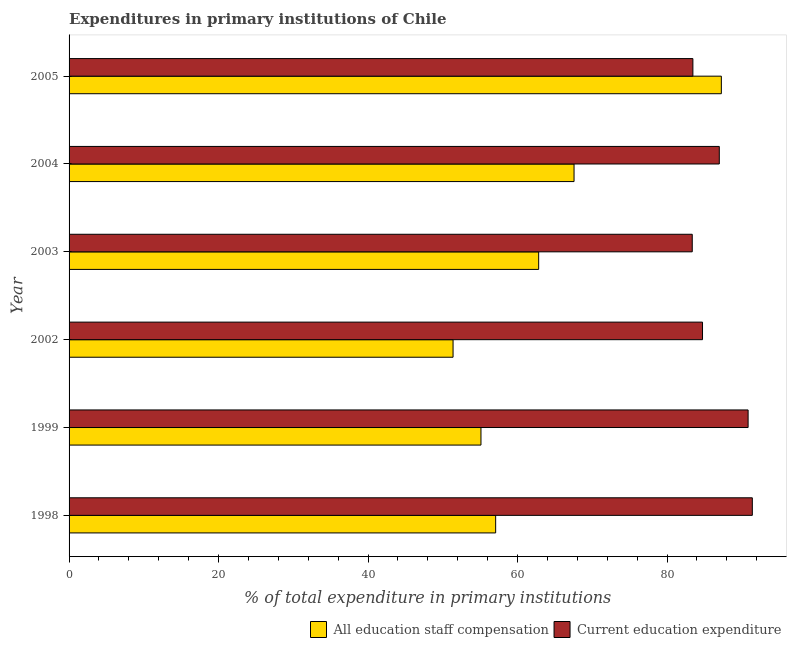How many groups of bars are there?
Provide a short and direct response. 6. Are the number of bars per tick equal to the number of legend labels?
Offer a terse response. Yes. How many bars are there on the 3rd tick from the top?
Provide a succinct answer. 2. How many bars are there on the 2nd tick from the bottom?
Your response must be concise. 2. In how many cases, is the number of bars for a given year not equal to the number of legend labels?
Offer a terse response. 0. What is the expenditure in education in 2005?
Your answer should be compact. 83.46. Across all years, what is the maximum expenditure in education?
Your answer should be very brief. 91.41. Across all years, what is the minimum expenditure in education?
Keep it short and to the point. 83.37. In which year was the expenditure in staff compensation maximum?
Your answer should be compact. 2005. What is the total expenditure in education in the graph?
Provide a succinct answer. 520.81. What is the difference between the expenditure in education in 1999 and that in 2005?
Your answer should be very brief. 7.39. What is the difference between the expenditure in staff compensation in 1998 and the expenditure in education in 2005?
Offer a terse response. -26.39. What is the average expenditure in education per year?
Offer a very short reply. 86.8. In the year 1999, what is the difference between the expenditure in staff compensation and expenditure in education?
Your response must be concise. -35.74. What is the ratio of the expenditure in staff compensation in 1998 to that in 1999?
Keep it short and to the point. 1.04. Is the expenditure in education in 1998 less than that in 2003?
Your response must be concise. No. What is the difference between the highest and the second highest expenditure in staff compensation?
Ensure brevity in your answer.  19.71. What is the difference between the highest and the lowest expenditure in education?
Make the answer very short. 8.04. Is the sum of the expenditure in education in 2002 and 2003 greater than the maximum expenditure in staff compensation across all years?
Your answer should be compact. Yes. What does the 2nd bar from the top in 1999 represents?
Make the answer very short. All education staff compensation. What does the 1st bar from the bottom in 1999 represents?
Your response must be concise. All education staff compensation. Are all the bars in the graph horizontal?
Keep it short and to the point. Yes. How many years are there in the graph?
Offer a very short reply. 6. Are the values on the major ticks of X-axis written in scientific E-notation?
Give a very brief answer. No. How are the legend labels stacked?
Provide a short and direct response. Horizontal. What is the title of the graph?
Make the answer very short. Expenditures in primary institutions of Chile. Does "Manufacturing industries and construction" appear as one of the legend labels in the graph?
Offer a very short reply. No. What is the label or title of the X-axis?
Keep it short and to the point. % of total expenditure in primary institutions. What is the label or title of the Y-axis?
Your answer should be very brief. Year. What is the % of total expenditure in primary institutions in All education staff compensation in 1998?
Provide a short and direct response. 57.07. What is the % of total expenditure in primary institutions of Current education expenditure in 1998?
Provide a short and direct response. 91.41. What is the % of total expenditure in primary institutions in All education staff compensation in 1999?
Offer a terse response. 55.1. What is the % of total expenditure in primary institutions in Current education expenditure in 1999?
Keep it short and to the point. 90.84. What is the % of total expenditure in primary institutions in All education staff compensation in 2002?
Ensure brevity in your answer.  51.37. What is the % of total expenditure in primary institutions in Current education expenditure in 2002?
Offer a very short reply. 84.74. What is the % of total expenditure in primary institutions in All education staff compensation in 2003?
Your response must be concise. 62.82. What is the % of total expenditure in primary institutions of Current education expenditure in 2003?
Your answer should be compact. 83.37. What is the % of total expenditure in primary institutions in All education staff compensation in 2004?
Keep it short and to the point. 67.56. What is the % of total expenditure in primary institutions in Current education expenditure in 2004?
Your answer should be compact. 86.99. What is the % of total expenditure in primary institutions of All education staff compensation in 2005?
Give a very brief answer. 87.26. What is the % of total expenditure in primary institutions in Current education expenditure in 2005?
Your response must be concise. 83.46. Across all years, what is the maximum % of total expenditure in primary institutions in All education staff compensation?
Make the answer very short. 87.26. Across all years, what is the maximum % of total expenditure in primary institutions in Current education expenditure?
Make the answer very short. 91.41. Across all years, what is the minimum % of total expenditure in primary institutions of All education staff compensation?
Keep it short and to the point. 51.37. Across all years, what is the minimum % of total expenditure in primary institutions of Current education expenditure?
Keep it short and to the point. 83.37. What is the total % of total expenditure in primary institutions of All education staff compensation in the graph?
Offer a terse response. 381.19. What is the total % of total expenditure in primary institutions of Current education expenditure in the graph?
Ensure brevity in your answer.  520.81. What is the difference between the % of total expenditure in primary institutions of All education staff compensation in 1998 and that in 1999?
Your answer should be compact. 1.97. What is the difference between the % of total expenditure in primary institutions of Current education expenditure in 1998 and that in 1999?
Your answer should be compact. 0.56. What is the difference between the % of total expenditure in primary institutions in All education staff compensation in 1998 and that in 2002?
Your answer should be compact. 5.7. What is the difference between the % of total expenditure in primary institutions of Current education expenditure in 1998 and that in 2002?
Offer a very short reply. 6.66. What is the difference between the % of total expenditure in primary institutions in All education staff compensation in 1998 and that in 2003?
Your response must be concise. -5.75. What is the difference between the % of total expenditure in primary institutions of Current education expenditure in 1998 and that in 2003?
Your answer should be compact. 8.04. What is the difference between the % of total expenditure in primary institutions in All education staff compensation in 1998 and that in 2004?
Provide a succinct answer. -10.49. What is the difference between the % of total expenditure in primary institutions of Current education expenditure in 1998 and that in 2004?
Your answer should be very brief. 4.42. What is the difference between the % of total expenditure in primary institutions of All education staff compensation in 1998 and that in 2005?
Give a very brief answer. -30.19. What is the difference between the % of total expenditure in primary institutions of Current education expenditure in 1998 and that in 2005?
Your answer should be very brief. 7.95. What is the difference between the % of total expenditure in primary institutions of All education staff compensation in 1999 and that in 2002?
Make the answer very short. 3.73. What is the difference between the % of total expenditure in primary institutions in Current education expenditure in 1999 and that in 2002?
Ensure brevity in your answer.  6.1. What is the difference between the % of total expenditure in primary institutions of All education staff compensation in 1999 and that in 2003?
Ensure brevity in your answer.  -7.72. What is the difference between the % of total expenditure in primary institutions of Current education expenditure in 1999 and that in 2003?
Make the answer very short. 7.47. What is the difference between the % of total expenditure in primary institutions of All education staff compensation in 1999 and that in 2004?
Your response must be concise. -12.45. What is the difference between the % of total expenditure in primary institutions in Current education expenditure in 1999 and that in 2004?
Your response must be concise. 3.85. What is the difference between the % of total expenditure in primary institutions in All education staff compensation in 1999 and that in 2005?
Make the answer very short. -32.16. What is the difference between the % of total expenditure in primary institutions in Current education expenditure in 1999 and that in 2005?
Keep it short and to the point. 7.39. What is the difference between the % of total expenditure in primary institutions in All education staff compensation in 2002 and that in 2003?
Offer a very short reply. -11.45. What is the difference between the % of total expenditure in primary institutions of Current education expenditure in 2002 and that in 2003?
Keep it short and to the point. 1.37. What is the difference between the % of total expenditure in primary institutions of All education staff compensation in 2002 and that in 2004?
Keep it short and to the point. -16.19. What is the difference between the % of total expenditure in primary institutions of Current education expenditure in 2002 and that in 2004?
Ensure brevity in your answer.  -2.24. What is the difference between the % of total expenditure in primary institutions of All education staff compensation in 2002 and that in 2005?
Offer a terse response. -35.89. What is the difference between the % of total expenditure in primary institutions in Current education expenditure in 2002 and that in 2005?
Provide a short and direct response. 1.29. What is the difference between the % of total expenditure in primary institutions of All education staff compensation in 2003 and that in 2004?
Ensure brevity in your answer.  -4.73. What is the difference between the % of total expenditure in primary institutions in Current education expenditure in 2003 and that in 2004?
Make the answer very short. -3.62. What is the difference between the % of total expenditure in primary institutions in All education staff compensation in 2003 and that in 2005?
Provide a short and direct response. -24.44. What is the difference between the % of total expenditure in primary institutions of Current education expenditure in 2003 and that in 2005?
Give a very brief answer. -0.09. What is the difference between the % of total expenditure in primary institutions in All education staff compensation in 2004 and that in 2005?
Your answer should be very brief. -19.71. What is the difference between the % of total expenditure in primary institutions in Current education expenditure in 2004 and that in 2005?
Your answer should be compact. 3.53. What is the difference between the % of total expenditure in primary institutions in All education staff compensation in 1998 and the % of total expenditure in primary institutions in Current education expenditure in 1999?
Offer a very short reply. -33.77. What is the difference between the % of total expenditure in primary institutions of All education staff compensation in 1998 and the % of total expenditure in primary institutions of Current education expenditure in 2002?
Make the answer very short. -27.67. What is the difference between the % of total expenditure in primary institutions in All education staff compensation in 1998 and the % of total expenditure in primary institutions in Current education expenditure in 2003?
Provide a succinct answer. -26.3. What is the difference between the % of total expenditure in primary institutions of All education staff compensation in 1998 and the % of total expenditure in primary institutions of Current education expenditure in 2004?
Make the answer very short. -29.92. What is the difference between the % of total expenditure in primary institutions in All education staff compensation in 1998 and the % of total expenditure in primary institutions in Current education expenditure in 2005?
Make the answer very short. -26.39. What is the difference between the % of total expenditure in primary institutions in All education staff compensation in 1999 and the % of total expenditure in primary institutions in Current education expenditure in 2002?
Provide a short and direct response. -29.64. What is the difference between the % of total expenditure in primary institutions of All education staff compensation in 1999 and the % of total expenditure in primary institutions of Current education expenditure in 2003?
Provide a short and direct response. -28.27. What is the difference between the % of total expenditure in primary institutions of All education staff compensation in 1999 and the % of total expenditure in primary institutions of Current education expenditure in 2004?
Offer a very short reply. -31.88. What is the difference between the % of total expenditure in primary institutions in All education staff compensation in 1999 and the % of total expenditure in primary institutions in Current education expenditure in 2005?
Give a very brief answer. -28.35. What is the difference between the % of total expenditure in primary institutions in All education staff compensation in 2002 and the % of total expenditure in primary institutions in Current education expenditure in 2003?
Your response must be concise. -32. What is the difference between the % of total expenditure in primary institutions of All education staff compensation in 2002 and the % of total expenditure in primary institutions of Current education expenditure in 2004?
Ensure brevity in your answer.  -35.62. What is the difference between the % of total expenditure in primary institutions in All education staff compensation in 2002 and the % of total expenditure in primary institutions in Current education expenditure in 2005?
Keep it short and to the point. -32.09. What is the difference between the % of total expenditure in primary institutions of All education staff compensation in 2003 and the % of total expenditure in primary institutions of Current education expenditure in 2004?
Offer a very short reply. -24.16. What is the difference between the % of total expenditure in primary institutions in All education staff compensation in 2003 and the % of total expenditure in primary institutions in Current education expenditure in 2005?
Keep it short and to the point. -20.63. What is the difference between the % of total expenditure in primary institutions of All education staff compensation in 2004 and the % of total expenditure in primary institutions of Current education expenditure in 2005?
Ensure brevity in your answer.  -15.9. What is the average % of total expenditure in primary institutions in All education staff compensation per year?
Your response must be concise. 63.53. What is the average % of total expenditure in primary institutions of Current education expenditure per year?
Offer a terse response. 86.8. In the year 1998, what is the difference between the % of total expenditure in primary institutions of All education staff compensation and % of total expenditure in primary institutions of Current education expenditure?
Provide a short and direct response. -34.34. In the year 1999, what is the difference between the % of total expenditure in primary institutions in All education staff compensation and % of total expenditure in primary institutions in Current education expenditure?
Make the answer very short. -35.74. In the year 2002, what is the difference between the % of total expenditure in primary institutions of All education staff compensation and % of total expenditure in primary institutions of Current education expenditure?
Provide a short and direct response. -33.37. In the year 2003, what is the difference between the % of total expenditure in primary institutions of All education staff compensation and % of total expenditure in primary institutions of Current education expenditure?
Your response must be concise. -20.55. In the year 2004, what is the difference between the % of total expenditure in primary institutions in All education staff compensation and % of total expenditure in primary institutions in Current education expenditure?
Make the answer very short. -19.43. In the year 2005, what is the difference between the % of total expenditure in primary institutions in All education staff compensation and % of total expenditure in primary institutions in Current education expenditure?
Offer a very short reply. 3.81. What is the ratio of the % of total expenditure in primary institutions of All education staff compensation in 1998 to that in 1999?
Offer a very short reply. 1.04. What is the ratio of the % of total expenditure in primary institutions in All education staff compensation in 1998 to that in 2002?
Give a very brief answer. 1.11. What is the ratio of the % of total expenditure in primary institutions of Current education expenditure in 1998 to that in 2002?
Your response must be concise. 1.08. What is the ratio of the % of total expenditure in primary institutions in All education staff compensation in 1998 to that in 2003?
Give a very brief answer. 0.91. What is the ratio of the % of total expenditure in primary institutions in Current education expenditure in 1998 to that in 2003?
Make the answer very short. 1.1. What is the ratio of the % of total expenditure in primary institutions of All education staff compensation in 1998 to that in 2004?
Provide a succinct answer. 0.84. What is the ratio of the % of total expenditure in primary institutions of Current education expenditure in 1998 to that in 2004?
Keep it short and to the point. 1.05. What is the ratio of the % of total expenditure in primary institutions of All education staff compensation in 1998 to that in 2005?
Your answer should be compact. 0.65. What is the ratio of the % of total expenditure in primary institutions in Current education expenditure in 1998 to that in 2005?
Provide a short and direct response. 1.1. What is the ratio of the % of total expenditure in primary institutions in All education staff compensation in 1999 to that in 2002?
Keep it short and to the point. 1.07. What is the ratio of the % of total expenditure in primary institutions of Current education expenditure in 1999 to that in 2002?
Offer a terse response. 1.07. What is the ratio of the % of total expenditure in primary institutions in All education staff compensation in 1999 to that in 2003?
Ensure brevity in your answer.  0.88. What is the ratio of the % of total expenditure in primary institutions in Current education expenditure in 1999 to that in 2003?
Your response must be concise. 1.09. What is the ratio of the % of total expenditure in primary institutions in All education staff compensation in 1999 to that in 2004?
Ensure brevity in your answer.  0.82. What is the ratio of the % of total expenditure in primary institutions in Current education expenditure in 1999 to that in 2004?
Provide a succinct answer. 1.04. What is the ratio of the % of total expenditure in primary institutions in All education staff compensation in 1999 to that in 2005?
Ensure brevity in your answer.  0.63. What is the ratio of the % of total expenditure in primary institutions of Current education expenditure in 1999 to that in 2005?
Your answer should be compact. 1.09. What is the ratio of the % of total expenditure in primary institutions of All education staff compensation in 2002 to that in 2003?
Provide a succinct answer. 0.82. What is the ratio of the % of total expenditure in primary institutions in Current education expenditure in 2002 to that in 2003?
Provide a short and direct response. 1.02. What is the ratio of the % of total expenditure in primary institutions in All education staff compensation in 2002 to that in 2004?
Your answer should be very brief. 0.76. What is the ratio of the % of total expenditure in primary institutions in Current education expenditure in 2002 to that in 2004?
Give a very brief answer. 0.97. What is the ratio of the % of total expenditure in primary institutions in All education staff compensation in 2002 to that in 2005?
Give a very brief answer. 0.59. What is the ratio of the % of total expenditure in primary institutions in Current education expenditure in 2002 to that in 2005?
Your answer should be very brief. 1.02. What is the ratio of the % of total expenditure in primary institutions of All education staff compensation in 2003 to that in 2004?
Your response must be concise. 0.93. What is the ratio of the % of total expenditure in primary institutions of Current education expenditure in 2003 to that in 2004?
Your response must be concise. 0.96. What is the ratio of the % of total expenditure in primary institutions in All education staff compensation in 2003 to that in 2005?
Give a very brief answer. 0.72. What is the ratio of the % of total expenditure in primary institutions of Current education expenditure in 2003 to that in 2005?
Provide a succinct answer. 1. What is the ratio of the % of total expenditure in primary institutions in All education staff compensation in 2004 to that in 2005?
Your answer should be very brief. 0.77. What is the ratio of the % of total expenditure in primary institutions of Current education expenditure in 2004 to that in 2005?
Ensure brevity in your answer.  1.04. What is the difference between the highest and the second highest % of total expenditure in primary institutions in All education staff compensation?
Offer a terse response. 19.71. What is the difference between the highest and the second highest % of total expenditure in primary institutions in Current education expenditure?
Your response must be concise. 0.56. What is the difference between the highest and the lowest % of total expenditure in primary institutions of All education staff compensation?
Offer a terse response. 35.89. What is the difference between the highest and the lowest % of total expenditure in primary institutions in Current education expenditure?
Provide a succinct answer. 8.04. 